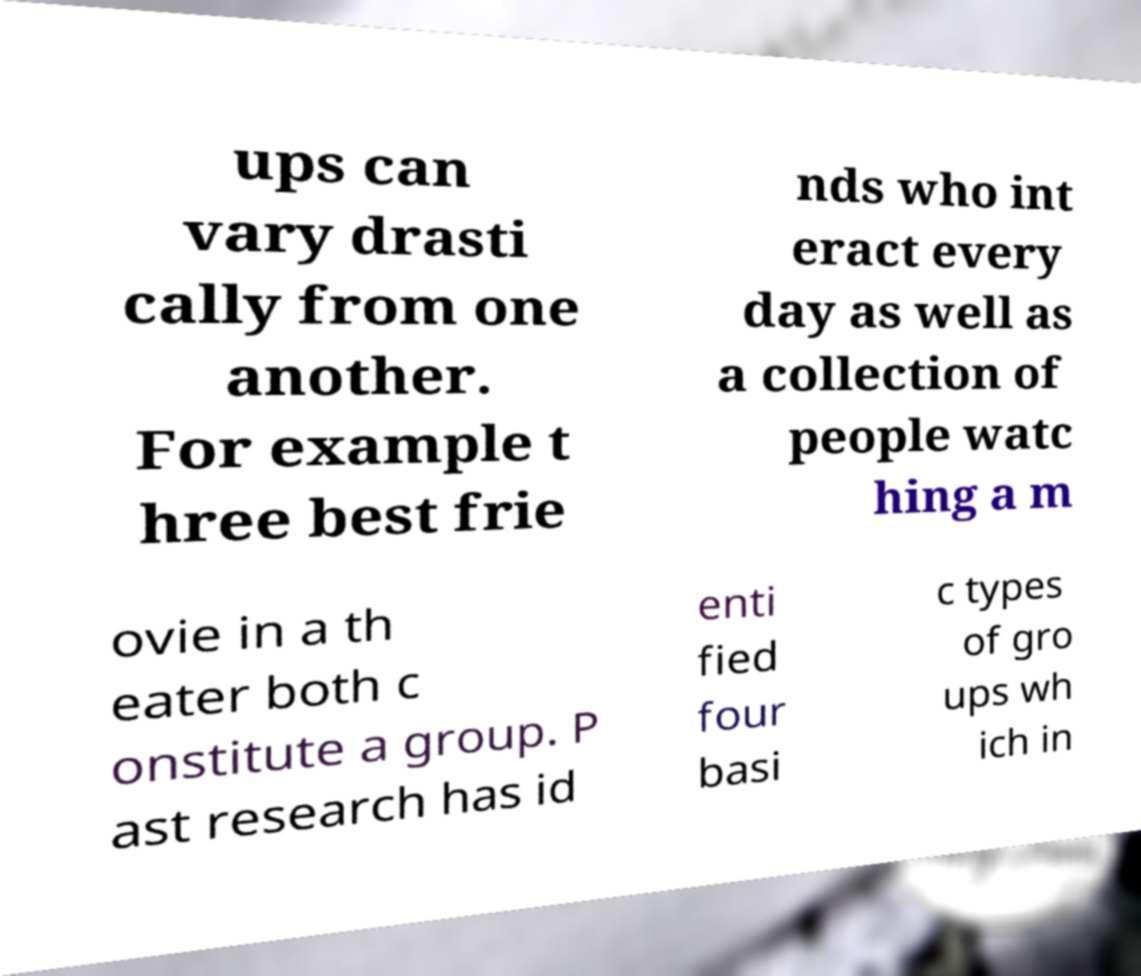I need the written content from this picture converted into text. Can you do that? ups can vary drasti cally from one another. For example t hree best frie nds who int eract every day as well as a collection of people watc hing a m ovie in a th eater both c onstitute a group. P ast research has id enti fied four basi c types of gro ups wh ich in 